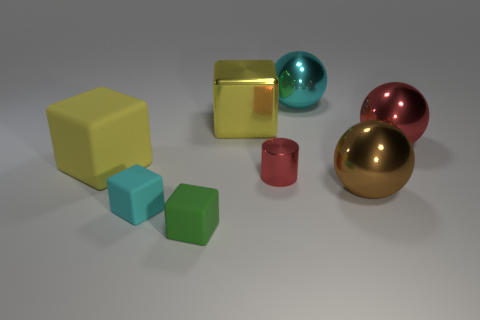Add 1 brown things. How many objects exist? 9 Subtract all spheres. How many objects are left? 5 Add 2 tiny purple metal cubes. How many tiny purple metal cubes exist? 2 Subtract 0 yellow cylinders. How many objects are left? 8 Subtract all yellow rubber cylinders. Subtract all metallic spheres. How many objects are left? 5 Add 4 large cyan balls. How many large cyan balls are left? 5 